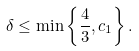Convert formula to latex. <formula><loc_0><loc_0><loc_500><loc_500>\delta \leq \min \left \{ \frac { 4 } { 3 } , c _ { 1 } \right \} .</formula> 